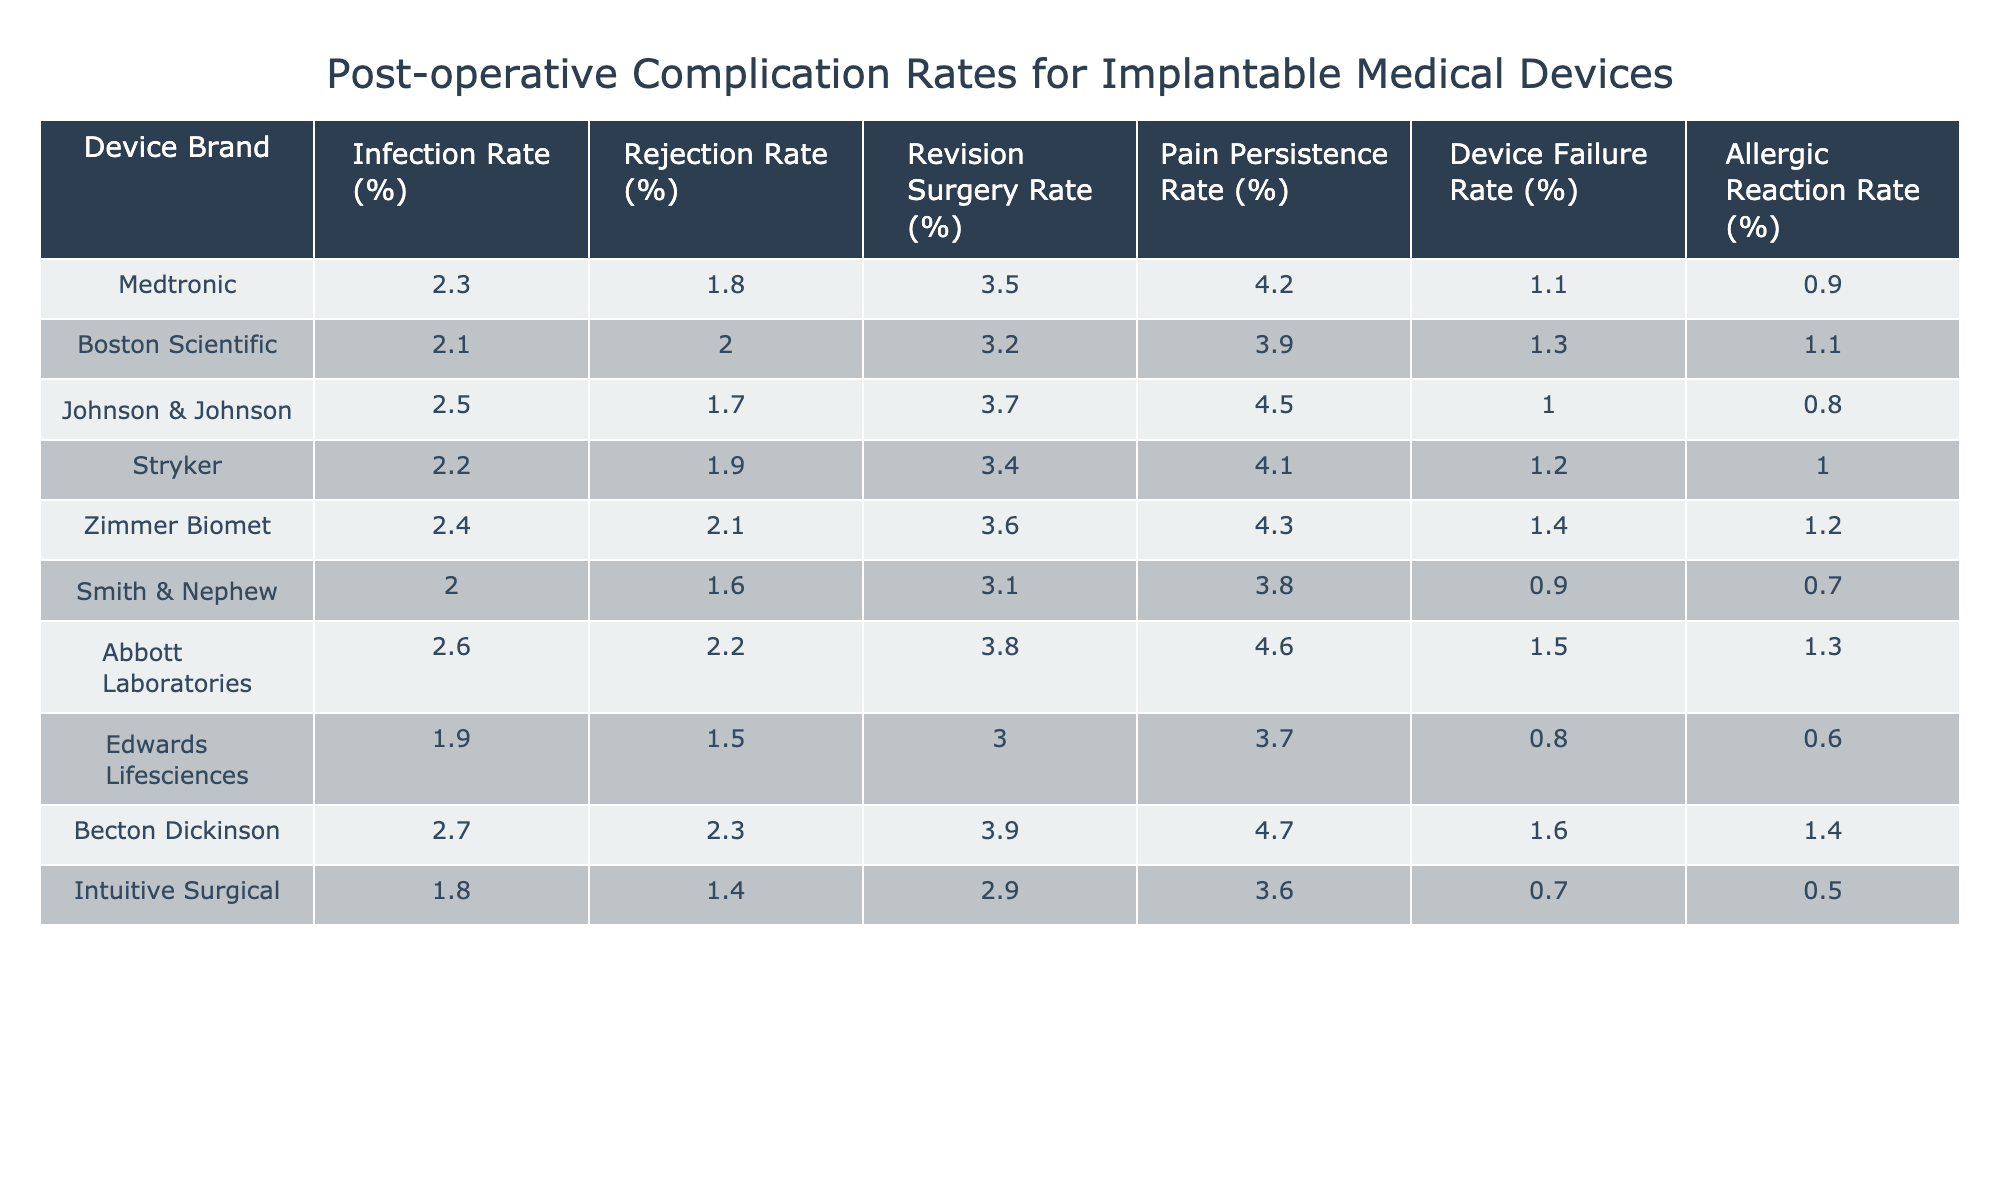What is the infection rate for the Abbott Laboratories device? The table lists the infection rate for Abbott Laboratories as 2.6%.
Answer: 2.6% Which device brand has the highest rejection rate? By comparing all the rejection rates in the table, Becton Dickinson has the highest rejection rate at 2.3%.
Answer: Becton Dickinson What is the average revision surgery rate across all device brands? The revision surgery rates are 3.5, 3.2, 3.7, 3.4, 3.6, 3.1, 3.8, 3.0, 3.9, and 2.9. Adding these gives a sum of 35.1, and dividing by 10 (the number of brands) results in an average of 3.51.
Answer: 3.5 Is the pain persistence rate for Johnson & Johnson higher than that for Smith & Nephew? Johnson & Johnson's pain persistence rate is 4.5% while Smith & Nephew's is 3.8%. Thus, Johnson & Johnson's rate is indeed higher.
Answer: Yes Which device has the lowest device failure rate? Scanning the table, Intuitive Surgical has the lowest device failure rate of 0.7%.
Answer: Intuitive Surgical What is the difference in infection rate between the best and worst performing brands? The best infection rate is 1.8% for Intuitive Surgical and the worst is 2.7% for Becton Dickinson. The difference is calculated as 2.7% - 1.8% = 0.9%.
Answer: 0.9% Does Stryker have a lower allergic reaction rate than Zimmer Biomet? The allergic reaction rate for Stryker is 1.0% and for Zimmer Biomet, it is 1.2%. Hence, Stryker has a lower allergic reaction rate.
Answer: Yes Which brand has the second highest pain persistence rate? The pain persistence rates in order from highest to lowest are 4.7%, 4.6%, 4.5%, 4.3%, 4.2%, and so on. The second highest is 4.6%, corresponding to Abbott Laboratories.
Answer: Abbott Laboratories If you combine the infection rates of Medtronic and Boston Scientific, what is their total? The infection rates for Medtronic and Boston Scientific are 2.3% and 2.1%, respectively. Adding these gives 2.3% + 2.1% = 4.4%.
Answer: 4.4% Considering the data, which brand could be considered the safest based on the lowest rates across all complications? By observing all the rates, Intuitive Surgical has the lowest rates in several categories, including infection and device failure, suggesting it could be the safest choice overall.
Answer: Intuitive Surgical 